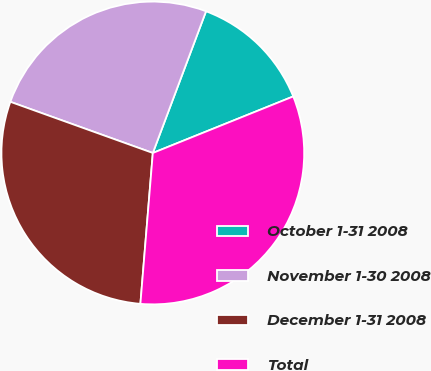Convert chart to OTSL. <chart><loc_0><loc_0><loc_500><loc_500><pie_chart><fcel>October 1-31 2008<fcel>November 1-30 2008<fcel>December 1-31 2008<fcel>Total<nl><fcel>13.19%<fcel>25.23%<fcel>29.18%<fcel>32.4%<nl></chart> 